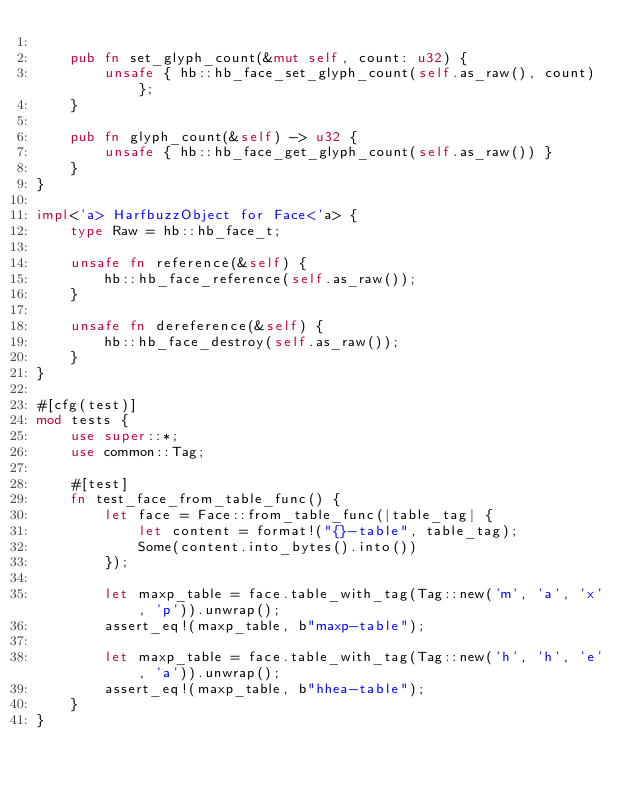<code> <loc_0><loc_0><loc_500><loc_500><_Rust_>
    pub fn set_glyph_count(&mut self, count: u32) {
        unsafe { hb::hb_face_set_glyph_count(self.as_raw(), count) };
    }

    pub fn glyph_count(&self) -> u32 {
        unsafe { hb::hb_face_get_glyph_count(self.as_raw()) }
    }
}

impl<'a> HarfbuzzObject for Face<'a> {
    type Raw = hb::hb_face_t;

    unsafe fn reference(&self) {
        hb::hb_face_reference(self.as_raw());
    }

    unsafe fn dereference(&self) {
        hb::hb_face_destroy(self.as_raw());
    }
}

#[cfg(test)]
mod tests {
    use super::*;
    use common::Tag;

    #[test]
    fn test_face_from_table_func() {
        let face = Face::from_table_func(|table_tag| {
            let content = format!("{}-table", table_tag);
            Some(content.into_bytes().into())
        });

        let maxp_table = face.table_with_tag(Tag::new('m', 'a', 'x', 'p')).unwrap();
        assert_eq!(maxp_table, b"maxp-table");

        let maxp_table = face.table_with_tag(Tag::new('h', 'h', 'e', 'a')).unwrap();
        assert_eq!(maxp_table, b"hhea-table");
    }
}
</code> 